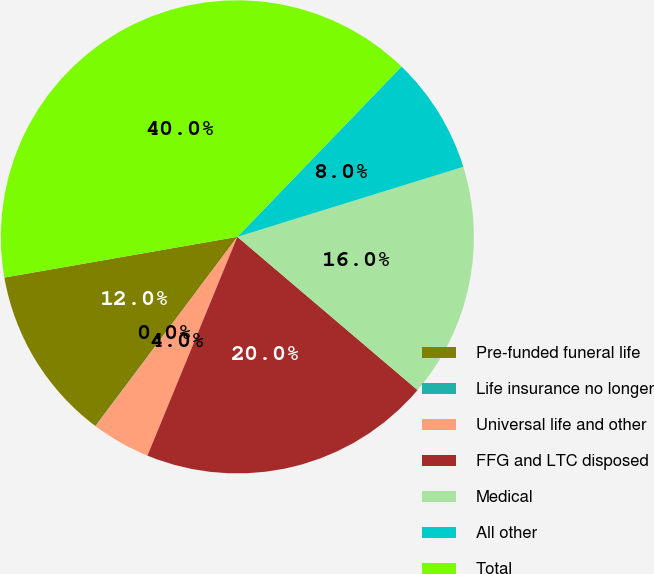<chart> <loc_0><loc_0><loc_500><loc_500><pie_chart><fcel>Pre-funded funeral life<fcel>Life insurance no longer<fcel>Universal life and other<fcel>FFG and LTC disposed<fcel>Medical<fcel>All other<fcel>Total<nl><fcel>12.0%<fcel>0.02%<fcel>4.02%<fcel>19.99%<fcel>16.0%<fcel>8.01%<fcel>39.96%<nl></chart> 